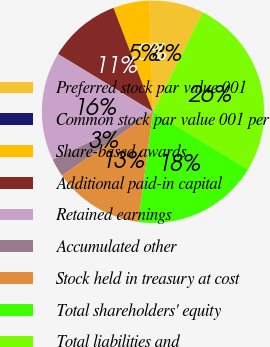Convert chart. <chart><loc_0><loc_0><loc_500><loc_500><pie_chart><fcel>Preferred stock par value 001<fcel>Common stock par value 001 per<fcel>Share-based awards<fcel>Additional paid-in capital<fcel>Retained earnings<fcel>Accumulated other<fcel>Stock held in treasury at cost<fcel>Total shareholders' equity<fcel>Total liabilities and<nl><fcel>7.89%<fcel>0.0%<fcel>5.26%<fcel>10.53%<fcel>15.79%<fcel>2.63%<fcel>13.16%<fcel>18.42%<fcel>26.32%<nl></chart> 